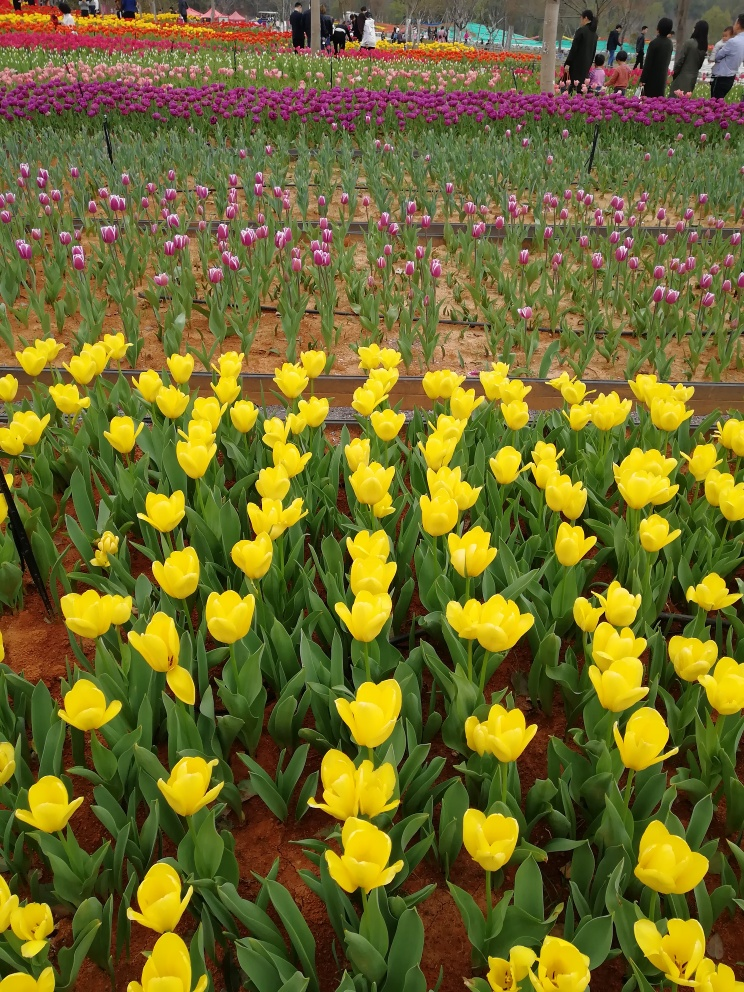Describe the quality of the image, and the provide a final evaluation This photograph features a meticulously maintained tulip garden, captured with exceptional clarity. The image is characterized by its sharp focus, allowing each tulip to stand out with remarkable detail. The colors are vivid and well-saturated, enhancing the visual appeal of the scene. The composition is well-balanced, with a diverse array of tulip colors that add depth and a lively sense to the photography. Overall, the image is of outstanding quality, inviting the viewer to appreciate the natural beauty and craftsmanship in garden management. 